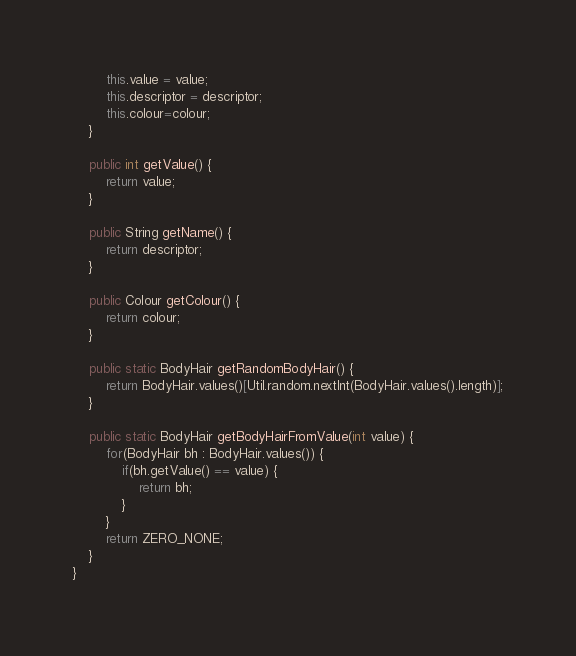Convert code to text. <code><loc_0><loc_0><loc_500><loc_500><_Java_>		this.value = value;
		this.descriptor = descriptor;
		this.colour=colour;
	}
	
	public int getValue() {
		return value;
	}

	public String getName() {
		return descriptor;
	}

	public Colour getColour() {
		return colour;
	}
	
	public static BodyHair getRandomBodyHair() {
		return BodyHair.values()[Util.random.nextInt(BodyHair.values().length)];
	}
	
	public static BodyHair getBodyHairFromValue(int value) {
		for(BodyHair bh : BodyHair.values()) {
			if(bh.getValue() == value) {
				return bh;
			}
		}
		return ZERO_NONE;
	}
}
</code> 